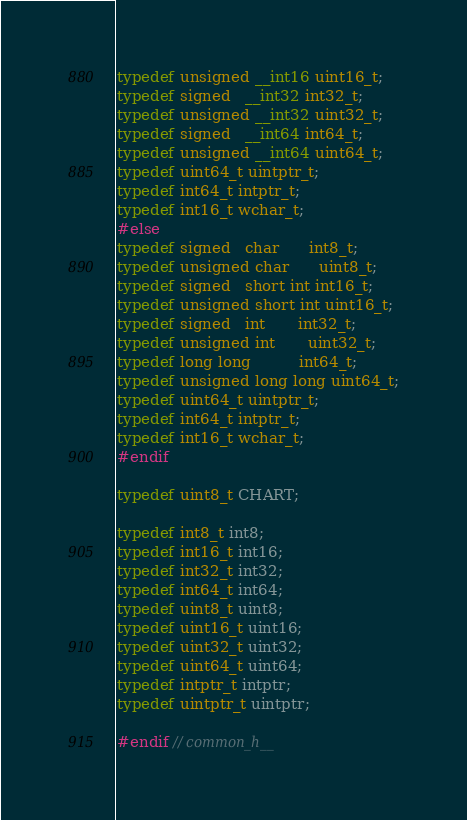Convert code to text. <code><loc_0><loc_0><loc_500><loc_500><_C_>typedef unsigned __int16 uint16_t;
typedef signed   __int32 int32_t;
typedef unsigned __int32 uint32_t;
typedef signed   __int64 int64_t;
typedef unsigned __int64 uint64_t;
typedef uint64_t uintptr_t;
typedef int64_t intptr_t;
typedef int16_t wchar_t;
#else
typedef signed   char      int8_t;
typedef unsigned char      uint8_t;
typedef signed   short int int16_t;
typedef unsigned short int uint16_t;
typedef signed   int       int32_t;
typedef unsigned int       uint32_t;
typedef long long          int64_t;
typedef unsigned long long uint64_t;
typedef uint64_t uintptr_t;
typedef int64_t intptr_t;
typedef int16_t wchar_t;
#endif

typedef uint8_t CHART;

typedef int8_t int8;
typedef int16_t int16;
typedef int32_t int32;
typedef int64_t int64;
typedef uint8_t uint8;
typedef uint16_t uint16;
typedef uint32_t uint32;
typedef uint64_t uint64;
typedef intptr_t intptr;
typedef uintptr_t uintptr;

#endif // common_h__</code> 